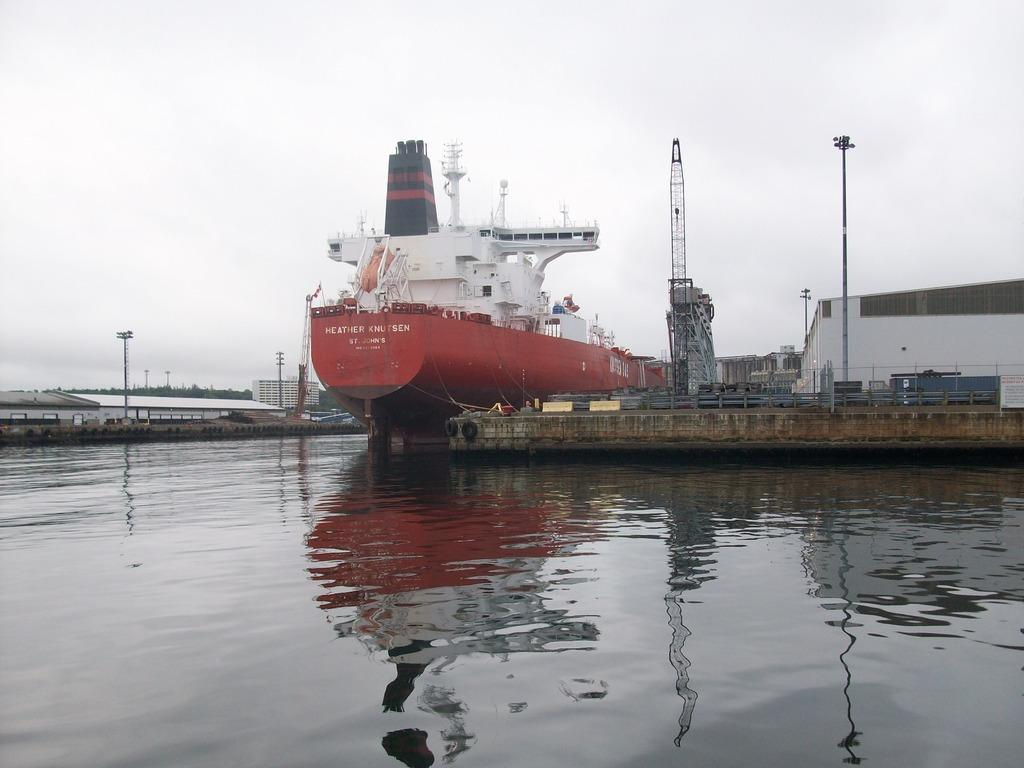<image>
Relay a brief, clear account of the picture shown. The ship named "Heather Knutsen" is in the water. 